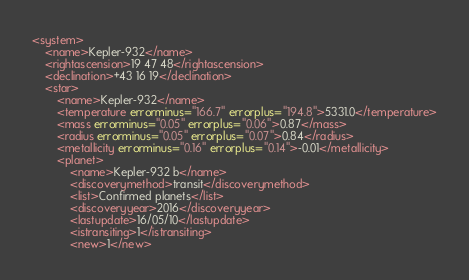<code> <loc_0><loc_0><loc_500><loc_500><_XML_><system>
	<name>Kepler-932</name>
	<rightascension>19 47 48</rightascension>
	<declination>+43 16 19</declination>
	<star>
		<name>Kepler-932</name>
		<temperature errorminus="166.7" errorplus="194.8">5331.0</temperature>
		<mass errorminus="0.05" errorplus="0.06">0.87</mass>
		<radius errorminus="0.05" errorplus="0.07">0.84</radius>
		<metallicity errorminus="0.16" errorplus="0.14">-0.01</metallicity>
		<planet>
			<name>Kepler-932 b</name>
			<discoverymethod>transit</discoverymethod>
			<list>Confirmed planets</list>
			<discoveryyear>2016</discoveryyear>
			<lastupdate>16/05/10</lastupdate>
			<istransiting>1</istransiting>
			<new>1</new></code> 